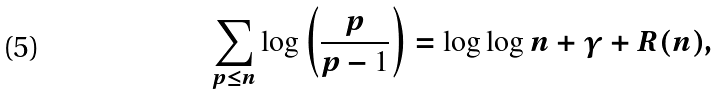Convert formula to latex. <formula><loc_0><loc_0><loc_500><loc_500>\sum _ { p \leq n } \log \left ( \frac { p } { p - 1 } \right ) = \log \log n + \gamma + R ( n ) ,</formula> 